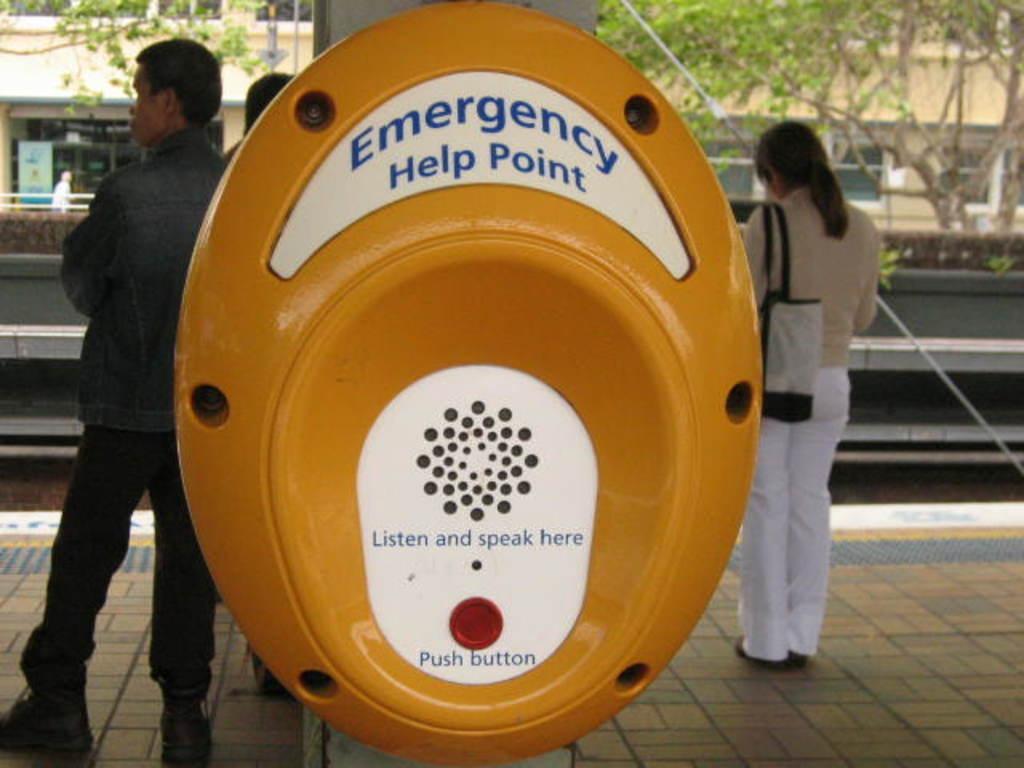In one or two sentences, can you explain what this image depicts? Front we can see a yellow device. Background there are people, building, trees and hoarding.  